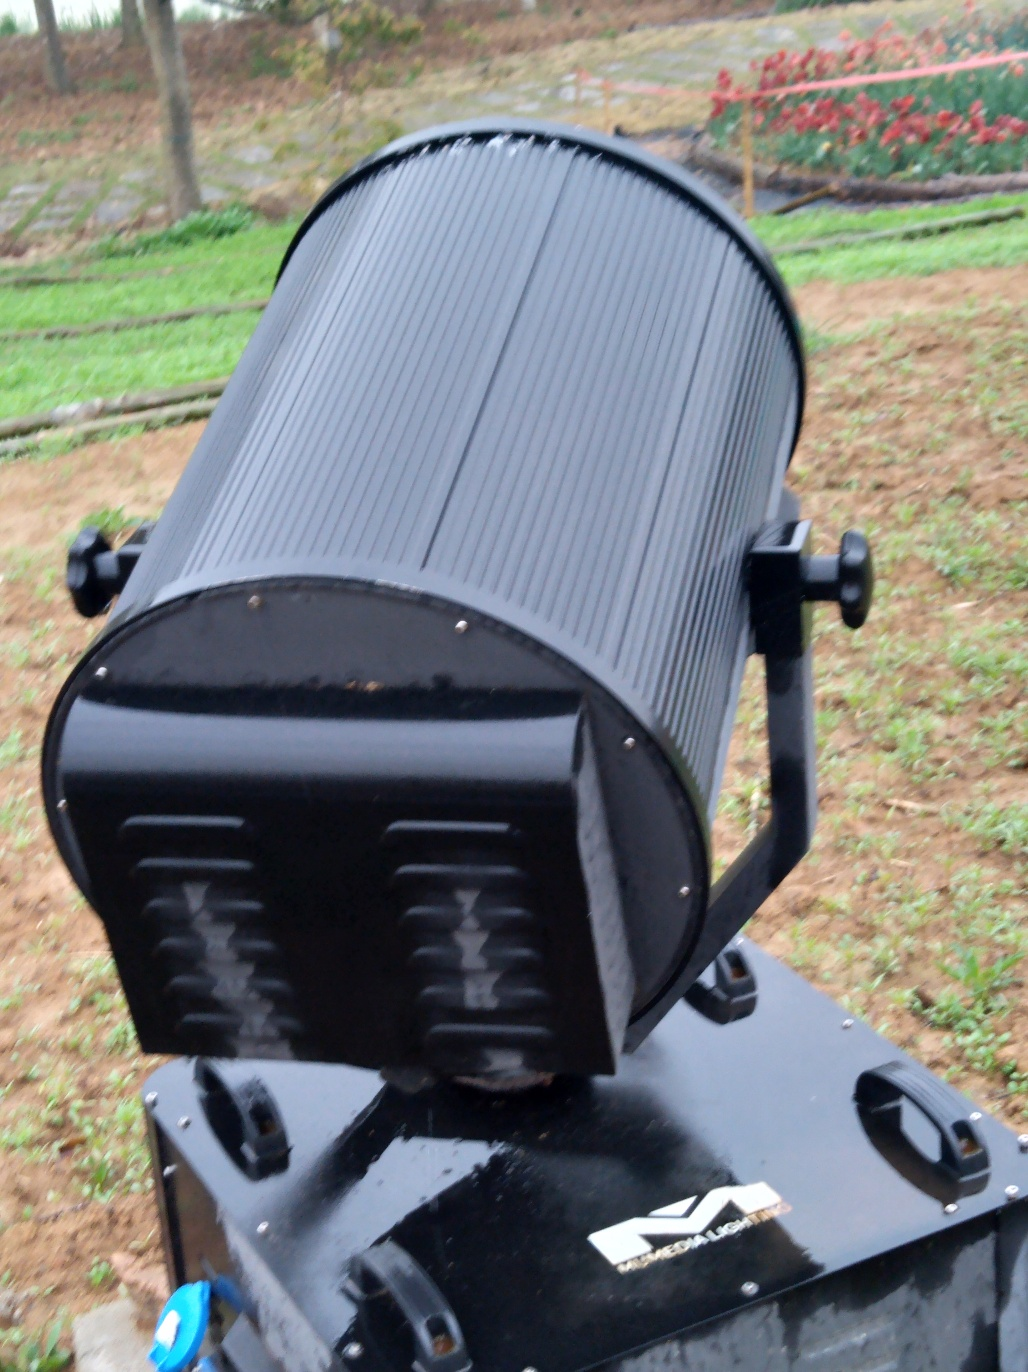What can be said about the texture details?
A. The texture details are excessively enhanced.
B. There are some texture details, but they are not well-preserved.
C. The texture details are completely missing.
D. The main subject preserves rich texture details.
Answer with the option's letter from the given choices directly.
 D. 